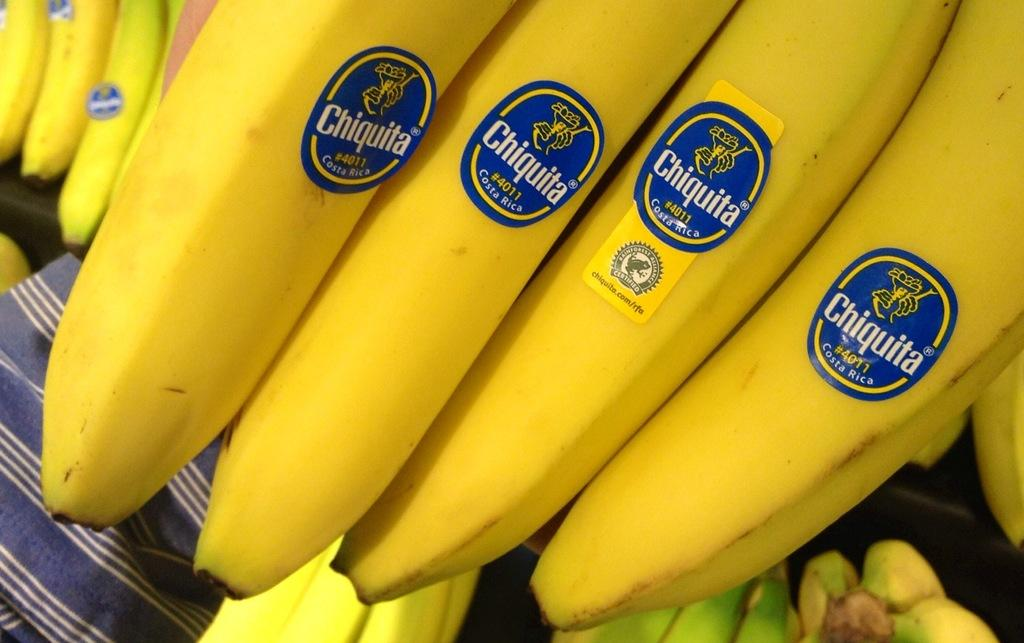What is the person in the image holding? The person is holding bananas in the image. Are there any distinguishing features on the bananas? Yes, the bananas have stickers on them. Can you describe the arrangement of the bananas in the image? There are bananas at the bottom of the image. What type of wind can be seen blowing through the image? There is no wind present in the image; it is a still image. 